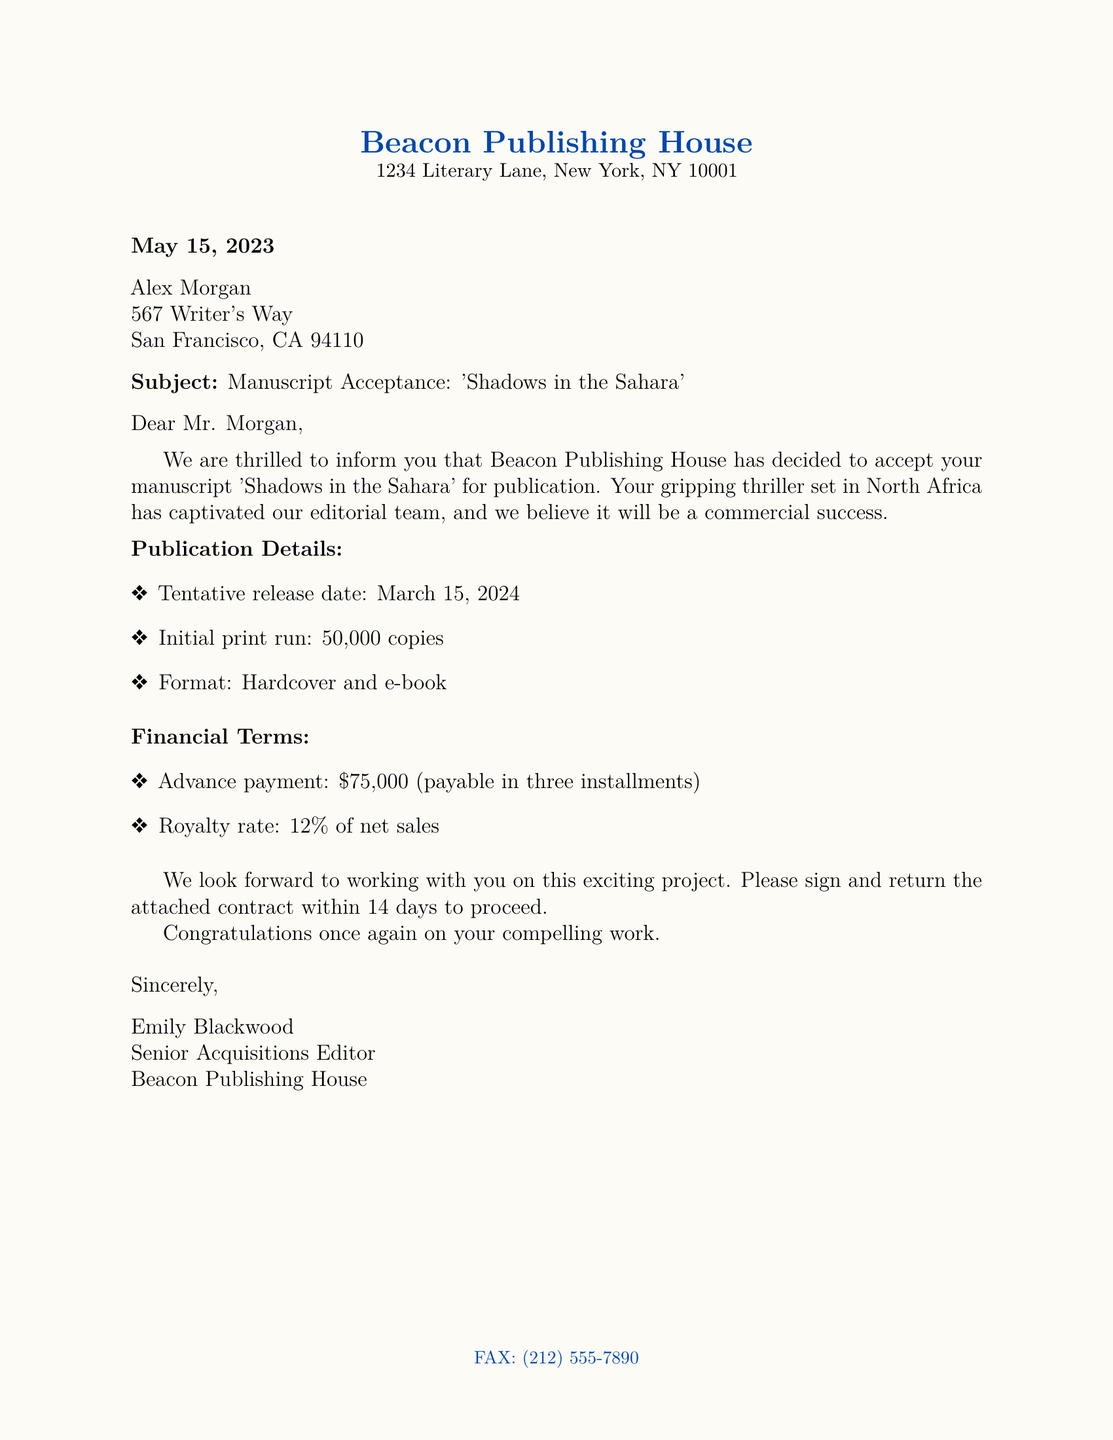What is the title of the accepted manuscript? The title of the manuscript mentioned in the letter is 'Shadows in the Sahara'.
Answer: 'Shadows in the Sahara' Who is the Senior Acquisitions Editor? The letter identifies Emily Blackwood as the Senior Acquisitions Editor of Beacon Publishing House.
Answer: Emily Blackwood When is the tentative release date? The letter specifies the manuscript's tentative release date as March 15, 2024.
Answer: March 15, 2024 What is the advance payment amount? The document states that the advance payment for the manuscript is $75,000.
Answer: $75,000 How many copies will be in the initial print run? The initial print run for the manuscript is noted to be 50,000 copies.
Answer: 50,000 copies What formats will the book be available in? The letter indicates that 'Shadows in the Sahara' will be available in hardcover and e-book formats.
Answer: Hardcover and e-book How long does the author have to return the contract? The document states the author has 14 days to sign and return the contract.
Answer: 14 days What is the royalty rate percentage offered? The letter specifies a royalty rate of 12% of net sales.
Answer: 12% What is the address of the publishing house? The address given for Beacon Publishing House in the document is 1234 Literary Lane, New York, NY 10001.
Answer: 1234 Literary Lane, New York, NY 10001 